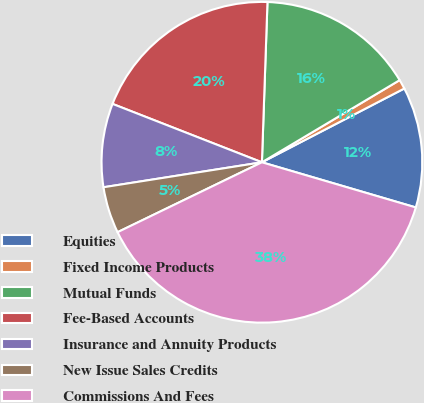Convert chart. <chart><loc_0><loc_0><loc_500><loc_500><pie_chart><fcel>Equities<fcel>Fixed Income Products<fcel>Mutual Funds<fcel>Fee-Based Accounts<fcel>Insurance and Annuity Products<fcel>New Issue Sales Credits<fcel>Commissions And Fees<nl><fcel>12.15%<fcel>0.95%<fcel>15.89%<fcel>19.62%<fcel>8.42%<fcel>4.69%<fcel>38.28%<nl></chart> 